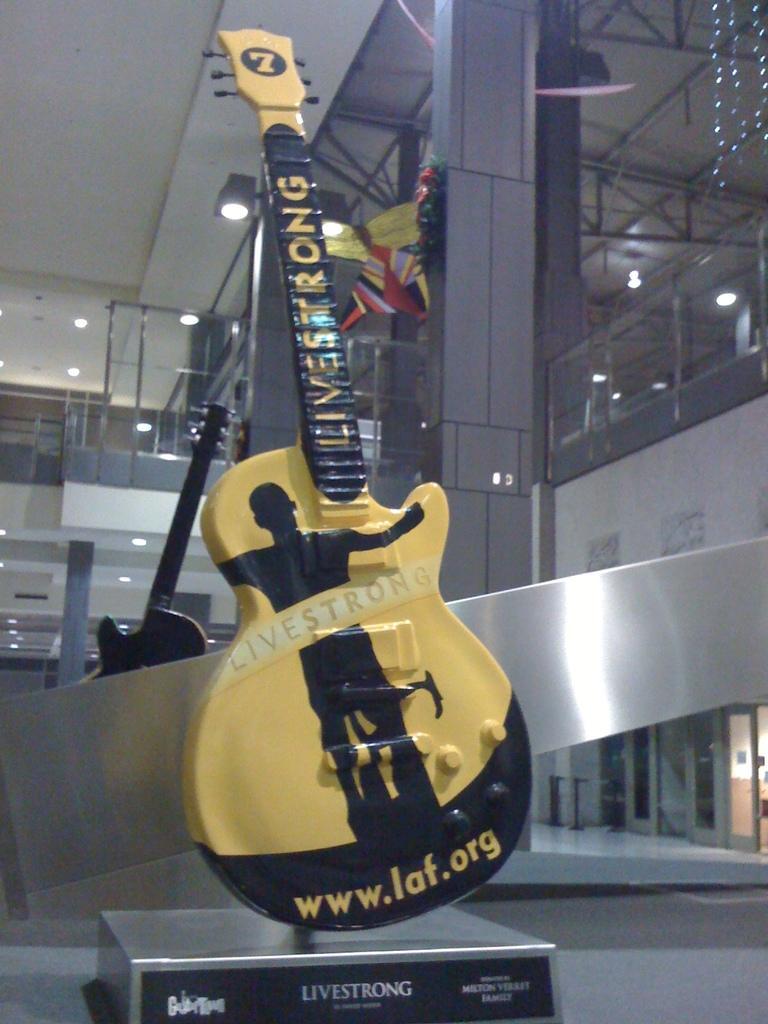Describe this image in one or two sentences. This picture is an inside view of a building. In the center of the image we can see a guitar. In the background of the image we can see the wall, lights, rods, reflection on the glass. At the top of the image we can see the roof. At the bottom of the image we can see the floor, board and doors. 